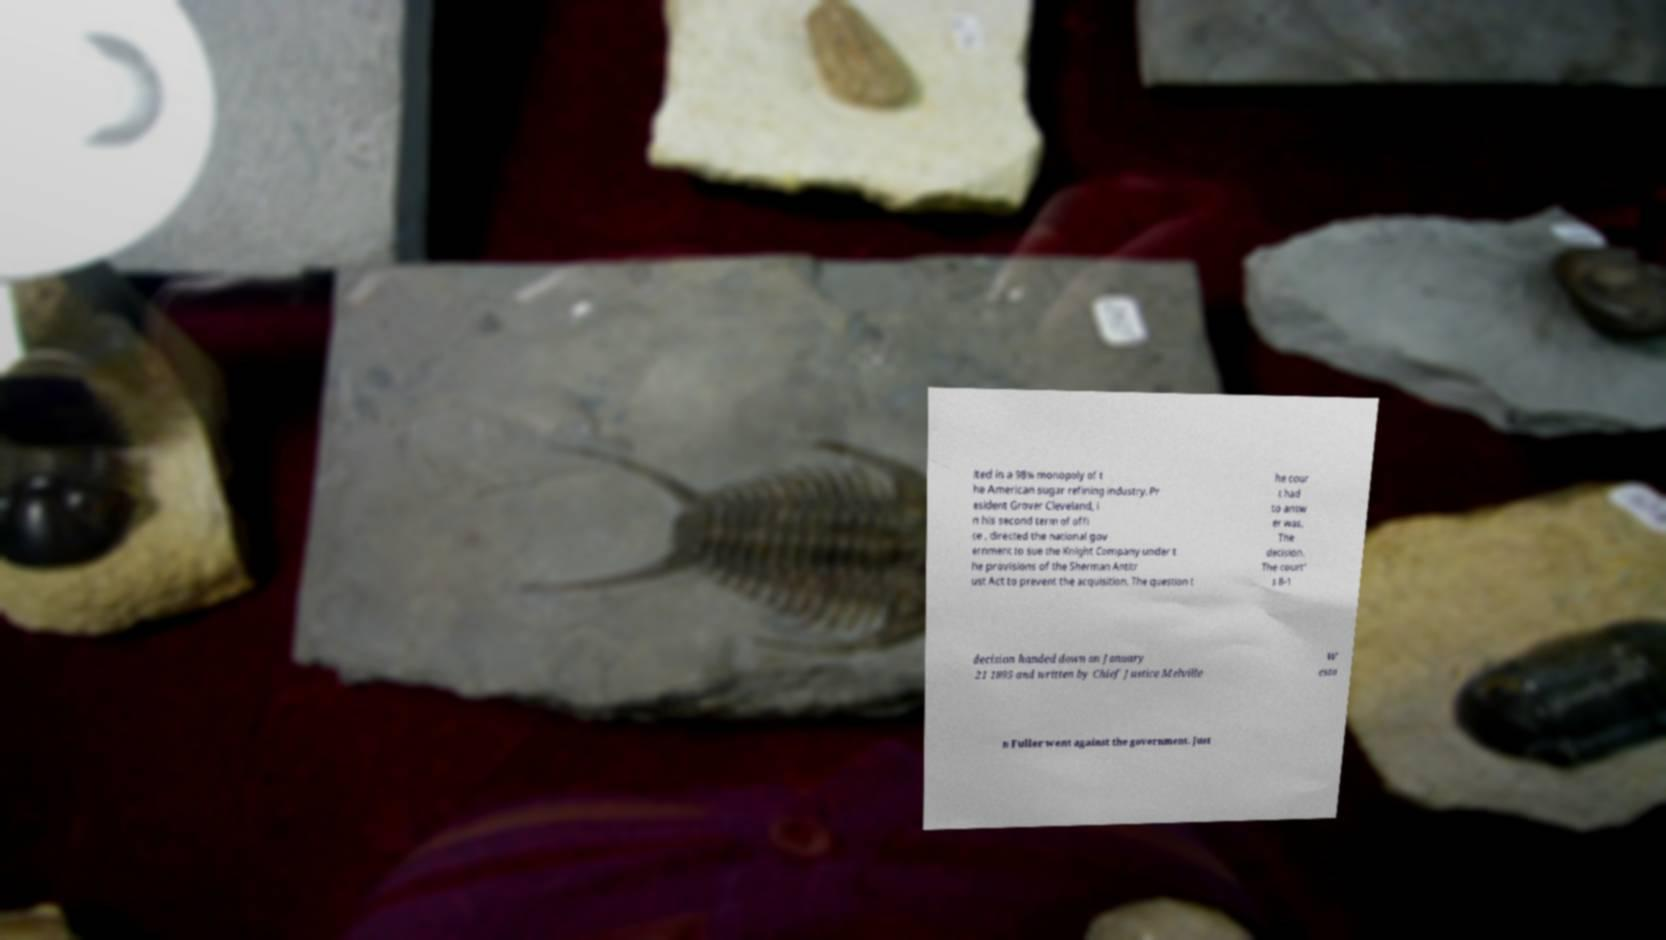What messages or text are displayed in this image? I need them in a readable, typed format. lted in a 98% monopoly of t he American sugar refining industry. Pr esident Grover Cleveland, i n his second term of offi ce , directed the national gov ernment to sue the Knight Company under t he provisions of the Sherman Antitr ust Act to prevent the acquisition. The question t he cour t had to answ er was, The decision. The court' s 8-1 decision handed down on January 21 1895 and written by Chief Justice Melville W esto n Fuller went against the government. Just 